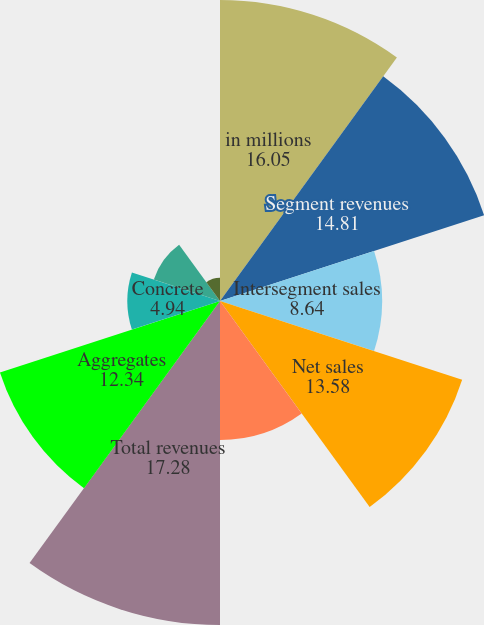Convert chart. <chart><loc_0><loc_0><loc_500><loc_500><pie_chart><fcel>in millions<fcel>Segment revenues<fcel>Intersegment sales<fcel>Net sales<fcel>Delivery revenues<fcel>Total revenues<fcel>Aggregates<fcel>Concrete<fcel>Asphalt Mix<fcel>Cement<nl><fcel>16.05%<fcel>14.81%<fcel>8.64%<fcel>13.58%<fcel>7.41%<fcel>17.28%<fcel>12.34%<fcel>4.94%<fcel>3.71%<fcel>1.24%<nl></chart> 